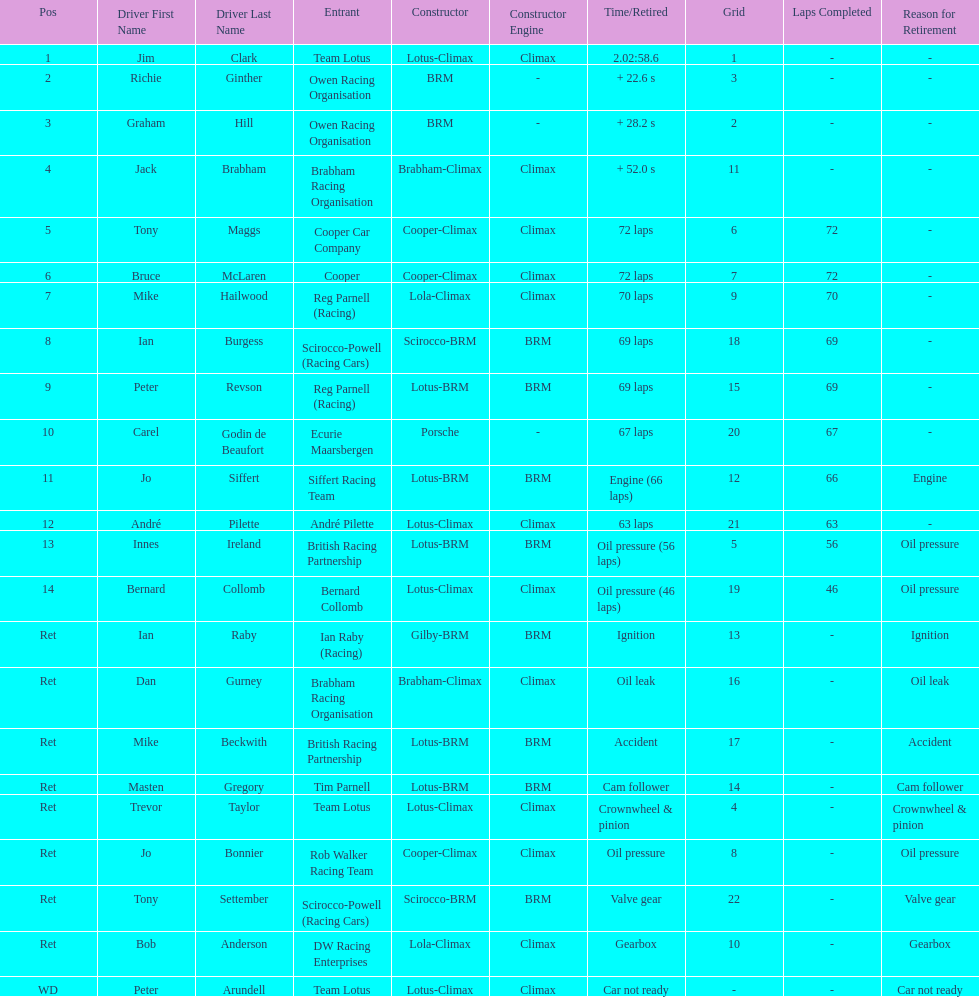How many different drivers are listed? 23. 